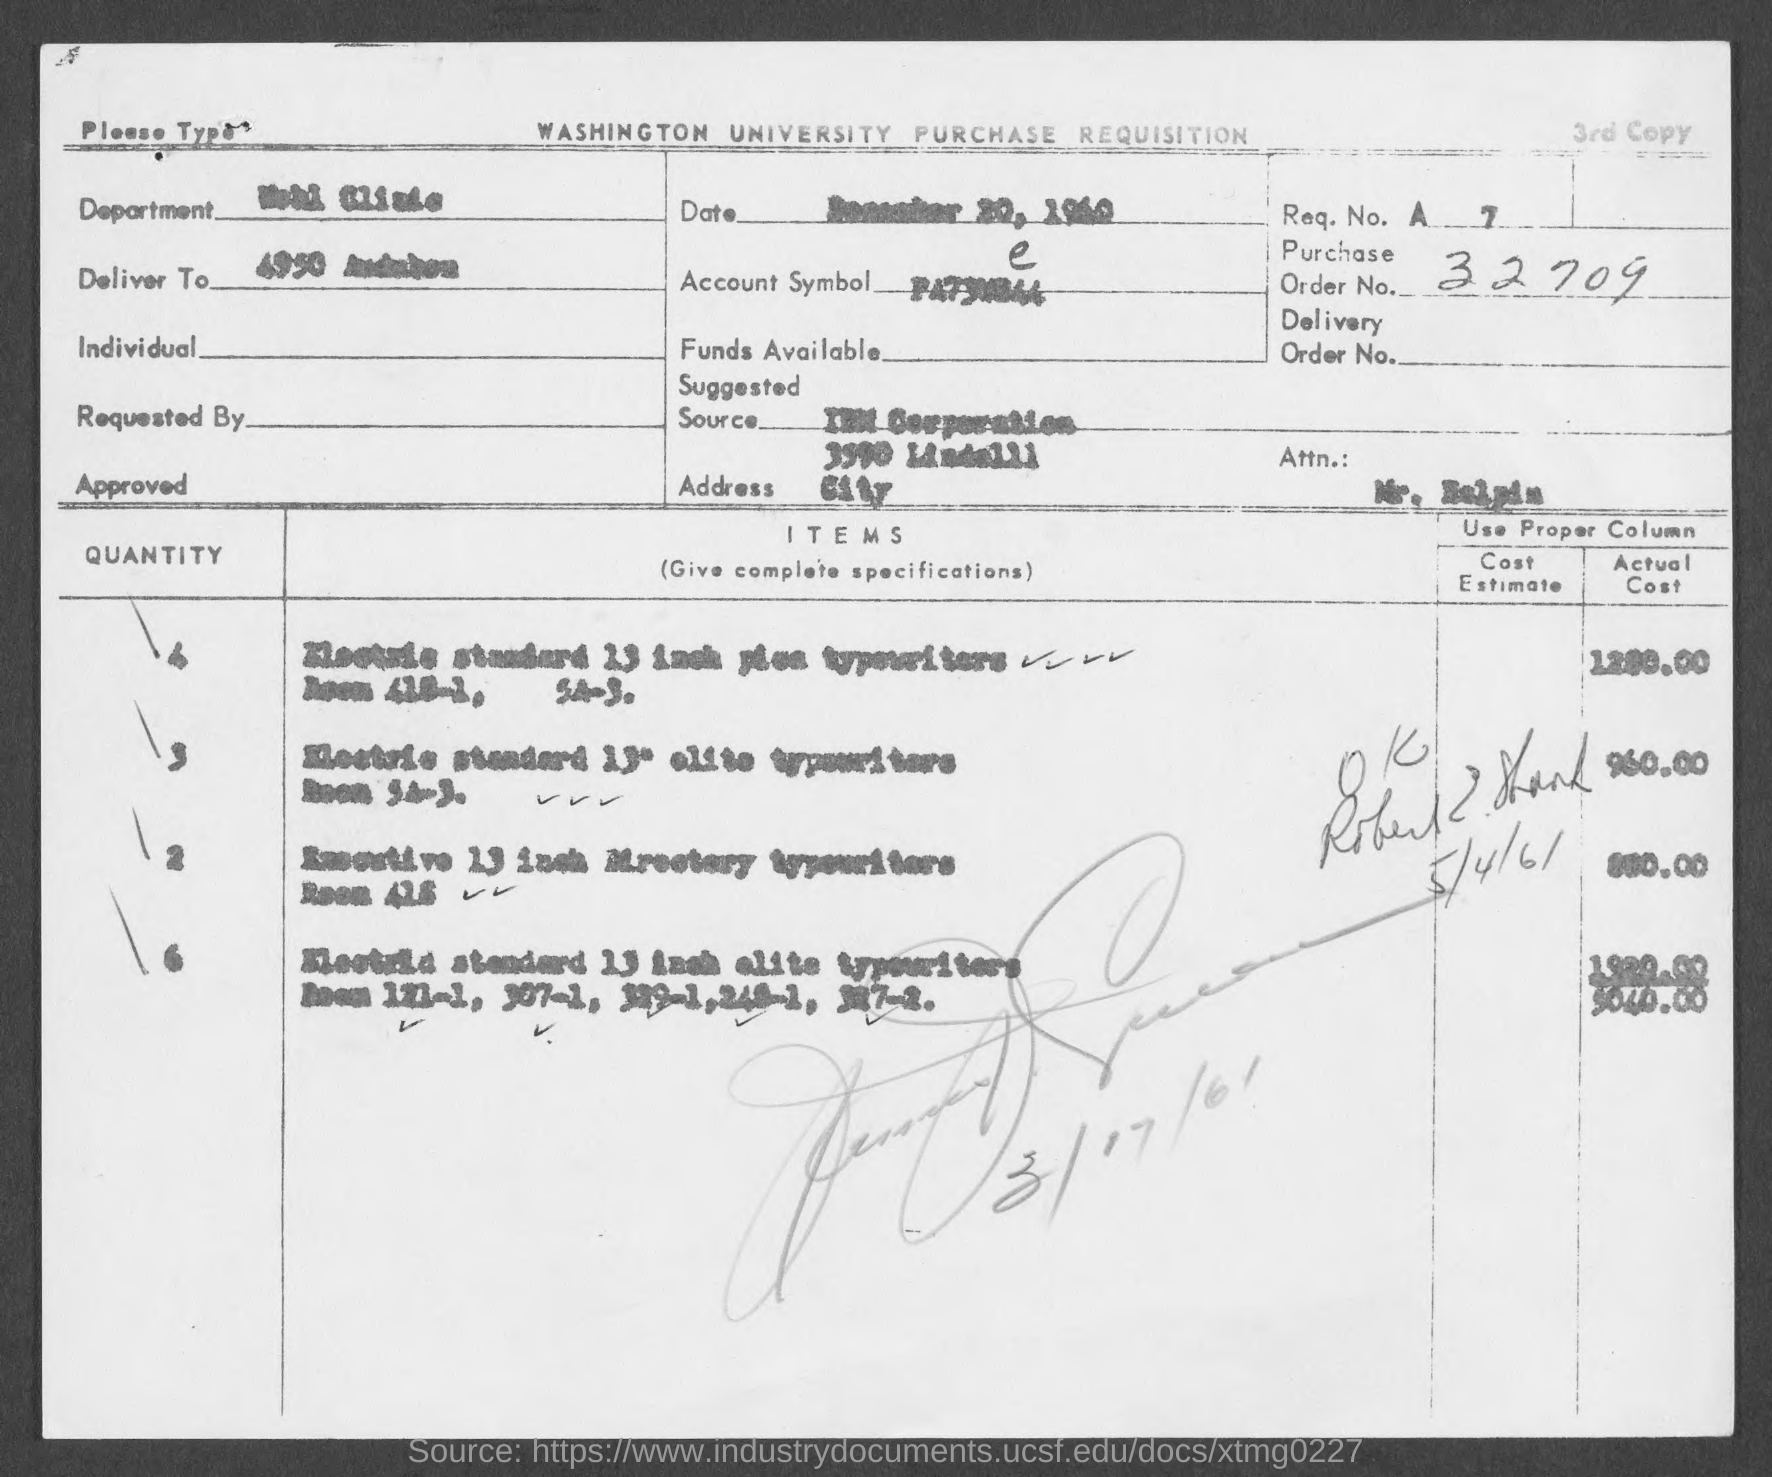Point out several critical features in this image. The order number is 32709. 